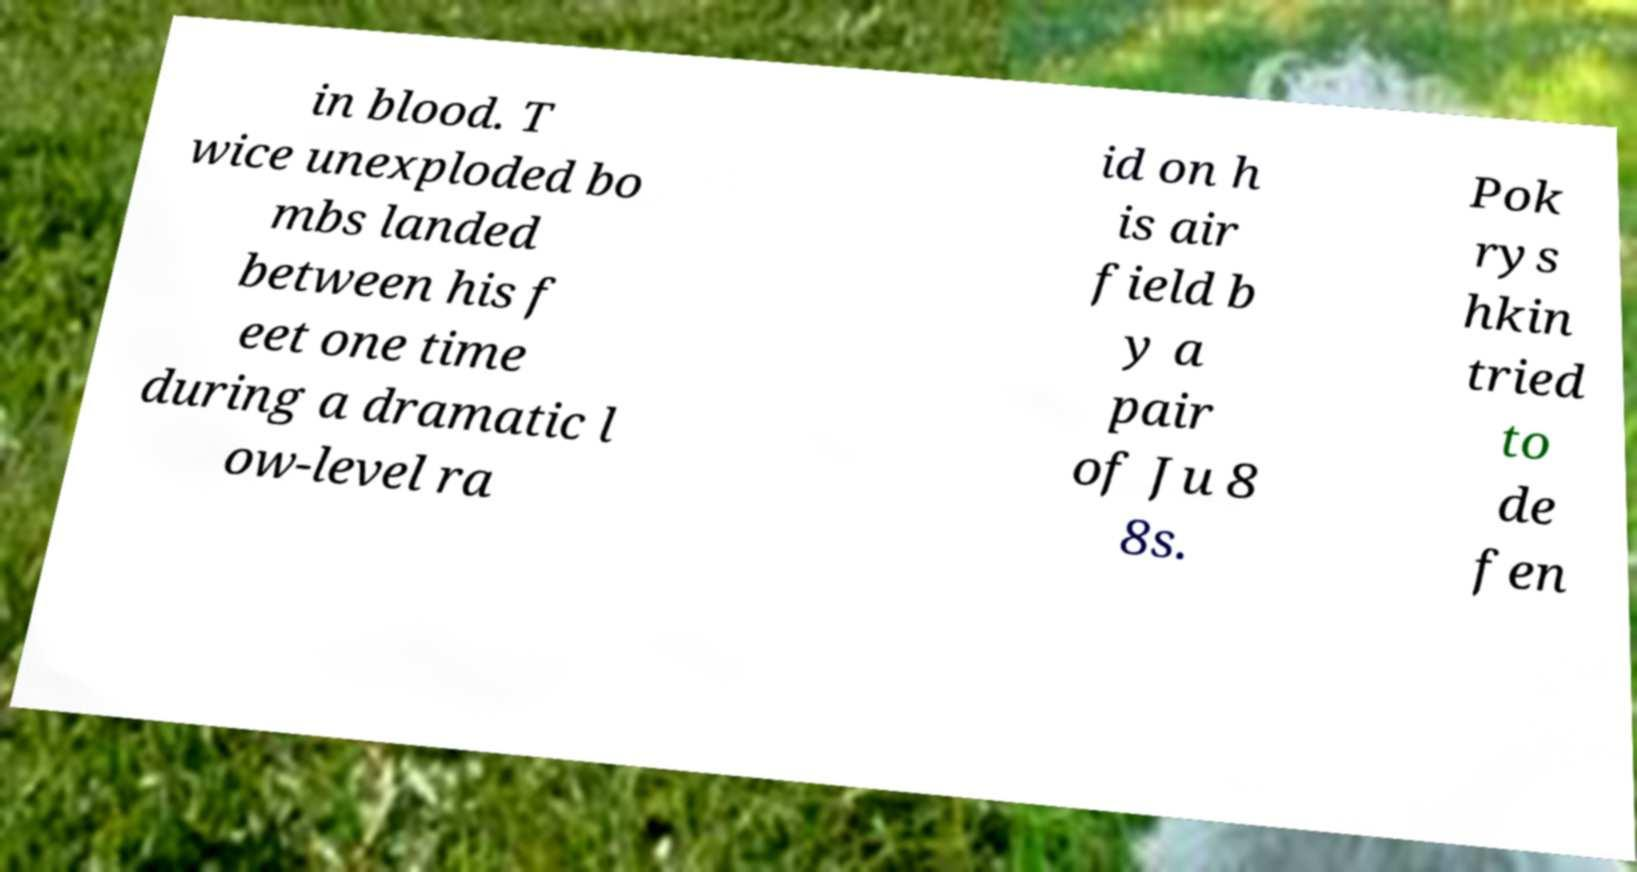I need the written content from this picture converted into text. Can you do that? in blood. T wice unexploded bo mbs landed between his f eet one time during a dramatic l ow-level ra id on h is air field b y a pair of Ju 8 8s. Pok rys hkin tried to de fen 